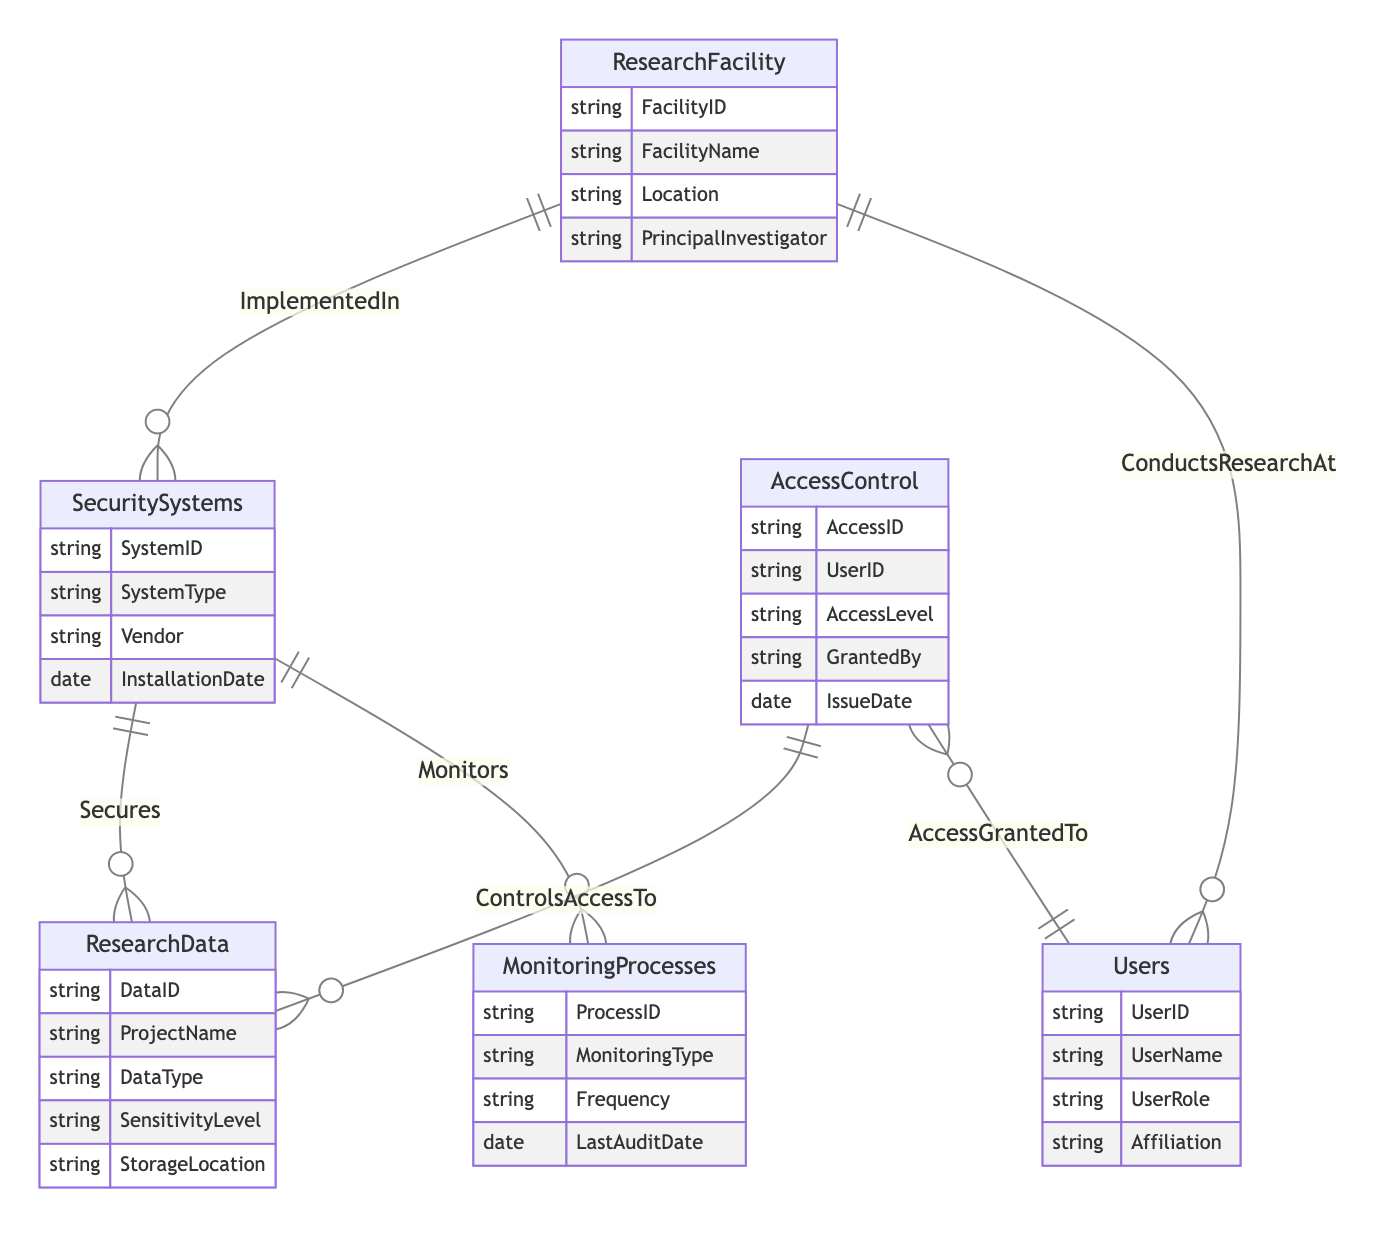What is the relationship type between Security Systems and Research Data? The diagram indicates that the relationship between Security Systems and Research Data is labeled as "Secures." By analyzing the ERD, we can observe that this relationship is represented as a OneToMany association, meaning one Security System can secure multiple Research Data entries.
Answer: OneToMany How many entities are present in the diagram? By counting the different entities defined in the ERD section of the diagram, we find that there are a total of six distinct entities: Research Facility, Security Systems, Research Data, Access Control, Monitoring Processes, and Users.
Answer: Six Which entity conducts research at a facility? According to the diagram, the relationship labeled "ConductsResearchAt" describes that Users are the ones who conduct research at a Research Facility. This is evident from the connecting line in the ERD indicating this specific relationship.
Answer: Users What attributes are present in the Research Data entity? The attributes associated with the Research Data entity, as shown in the diagram, include: DataID, ProjectName, DataType, SensitivityLevel, and StorageLocation. By reviewing the attributes listed under the Research Data entity, we can find this information directly.
Answer: DataID, ProjectName, DataType, SensitivityLevel, StorageLocation How frequently are Monitoring Processes conducted? The Monitoring Processes entity has an attribute called Frequency, which is relevant for determining how often monitoring is performed. By looking at the diagram, we recognize that this attribute indicates the regularity of the monitoring process, though the specific frequency value is not provided in the ERD.
Answer: Frequency Which entity is accessed through the Access Control? The diagram illustrates that Access Control controls access to Research Data, as indicated by the relationship labeled "ControlsAccessTo." Therefore, Research Data is the entity that is accessed through Access Control, as represented in this relationship.
Answer: Research Data What is the type of relationship between Security Systems and Monitoring Processes? The relationship between Security Systems and Monitoring Processes is represented by "Monitors" in the ERD, which is defined as a OneToMany type. This means one Security System can oversee multiple Monitoring Processes, indicating a hierarchical monitoring structure.
Answer: OneToMany Who grants access in the Access Control entity? The attribute grantedBy within the Access Control entity specifies the person responsible for granting access. In the context of the diagram, it identifies who issued the access privileges related to Research Data.
Answer: GrantedBy 